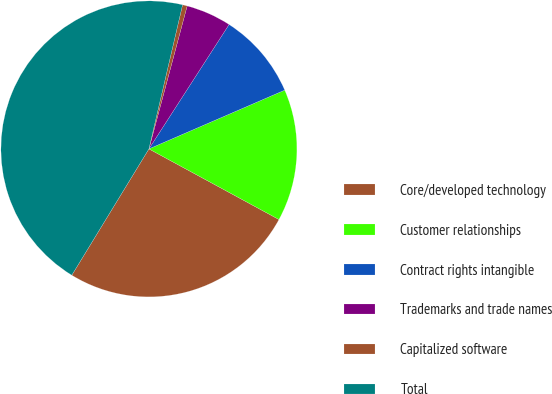<chart> <loc_0><loc_0><loc_500><loc_500><pie_chart><fcel>Core/developed technology<fcel>Customer relationships<fcel>Contract rights intangible<fcel>Trademarks and trade names<fcel>Capitalized software<fcel>Total<nl><fcel>25.81%<fcel>14.42%<fcel>9.39%<fcel>4.95%<fcel>0.51%<fcel>44.93%<nl></chart> 